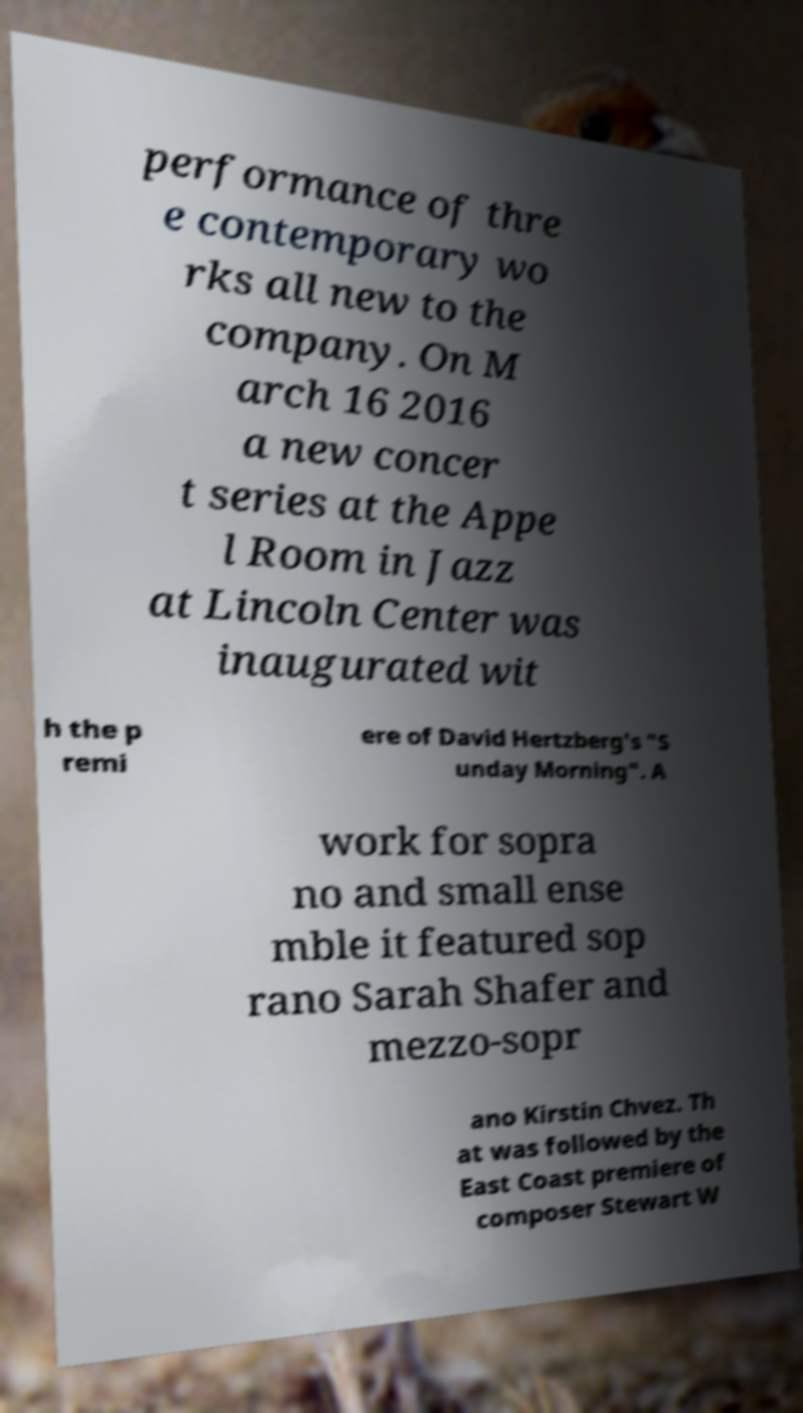I need the written content from this picture converted into text. Can you do that? performance of thre e contemporary wo rks all new to the company. On M arch 16 2016 a new concer t series at the Appe l Room in Jazz at Lincoln Center was inaugurated wit h the p remi ere of David Hertzberg's "S unday Morning". A work for sopra no and small ense mble it featured sop rano Sarah Shafer and mezzo-sopr ano Kirstin Chvez. Th at was followed by the East Coast premiere of composer Stewart W 